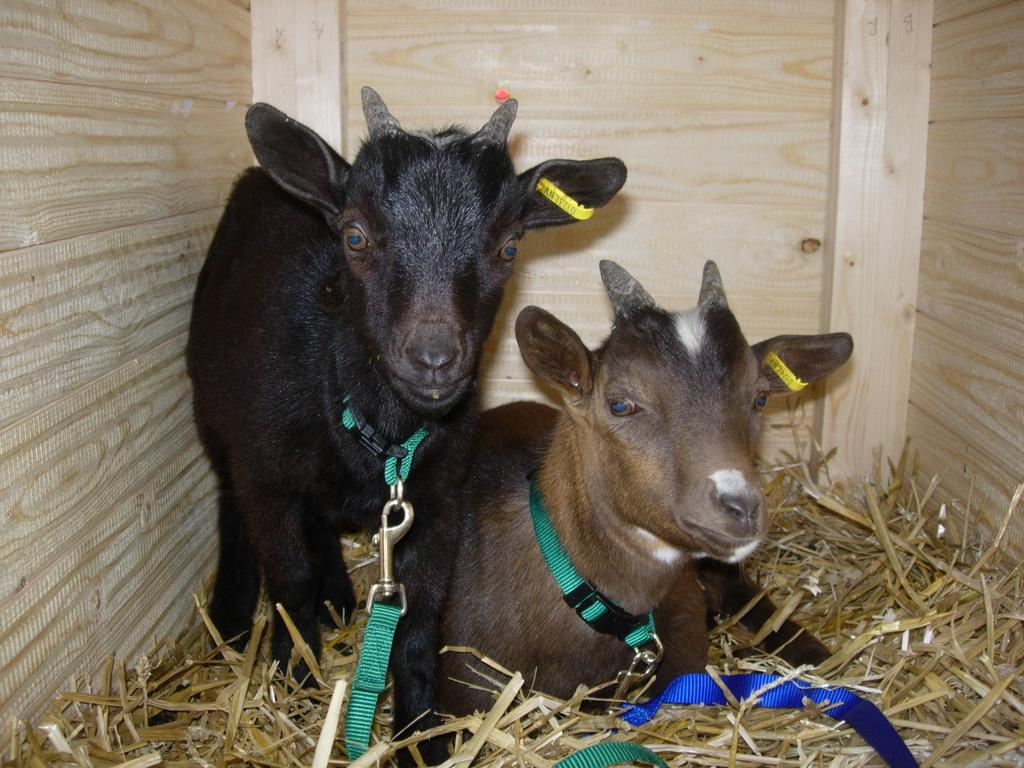How many animals are present in the image? There are two animals in the image. Where are the animals located? The animals are in a shed. What type of vegetation can be seen in the image? There is grass visible in the image. What actor is performing in the shed in the image? There is no actor present in the image; it features two animals in a shed. How does the mass of the animals affect the stability of the shed in the image? The mass of the animals is not mentioned in the image, and therefore we cannot determine its effect on the stability of the shed. 